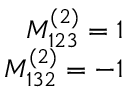<formula> <loc_0><loc_0><loc_500><loc_500>\begin{array} { r } { M _ { 1 2 3 } ^ { ( 2 ) } = 1 } \\ { M _ { 1 3 2 } ^ { ( 2 ) } = - 1 } \end{array}</formula> 